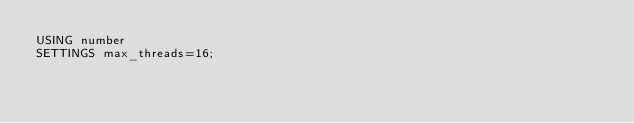Convert code to text. <code><loc_0><loc_0><loc_500><loc_500><_SQL_>USING number
SETTINGS max_threads=16;
</code> 